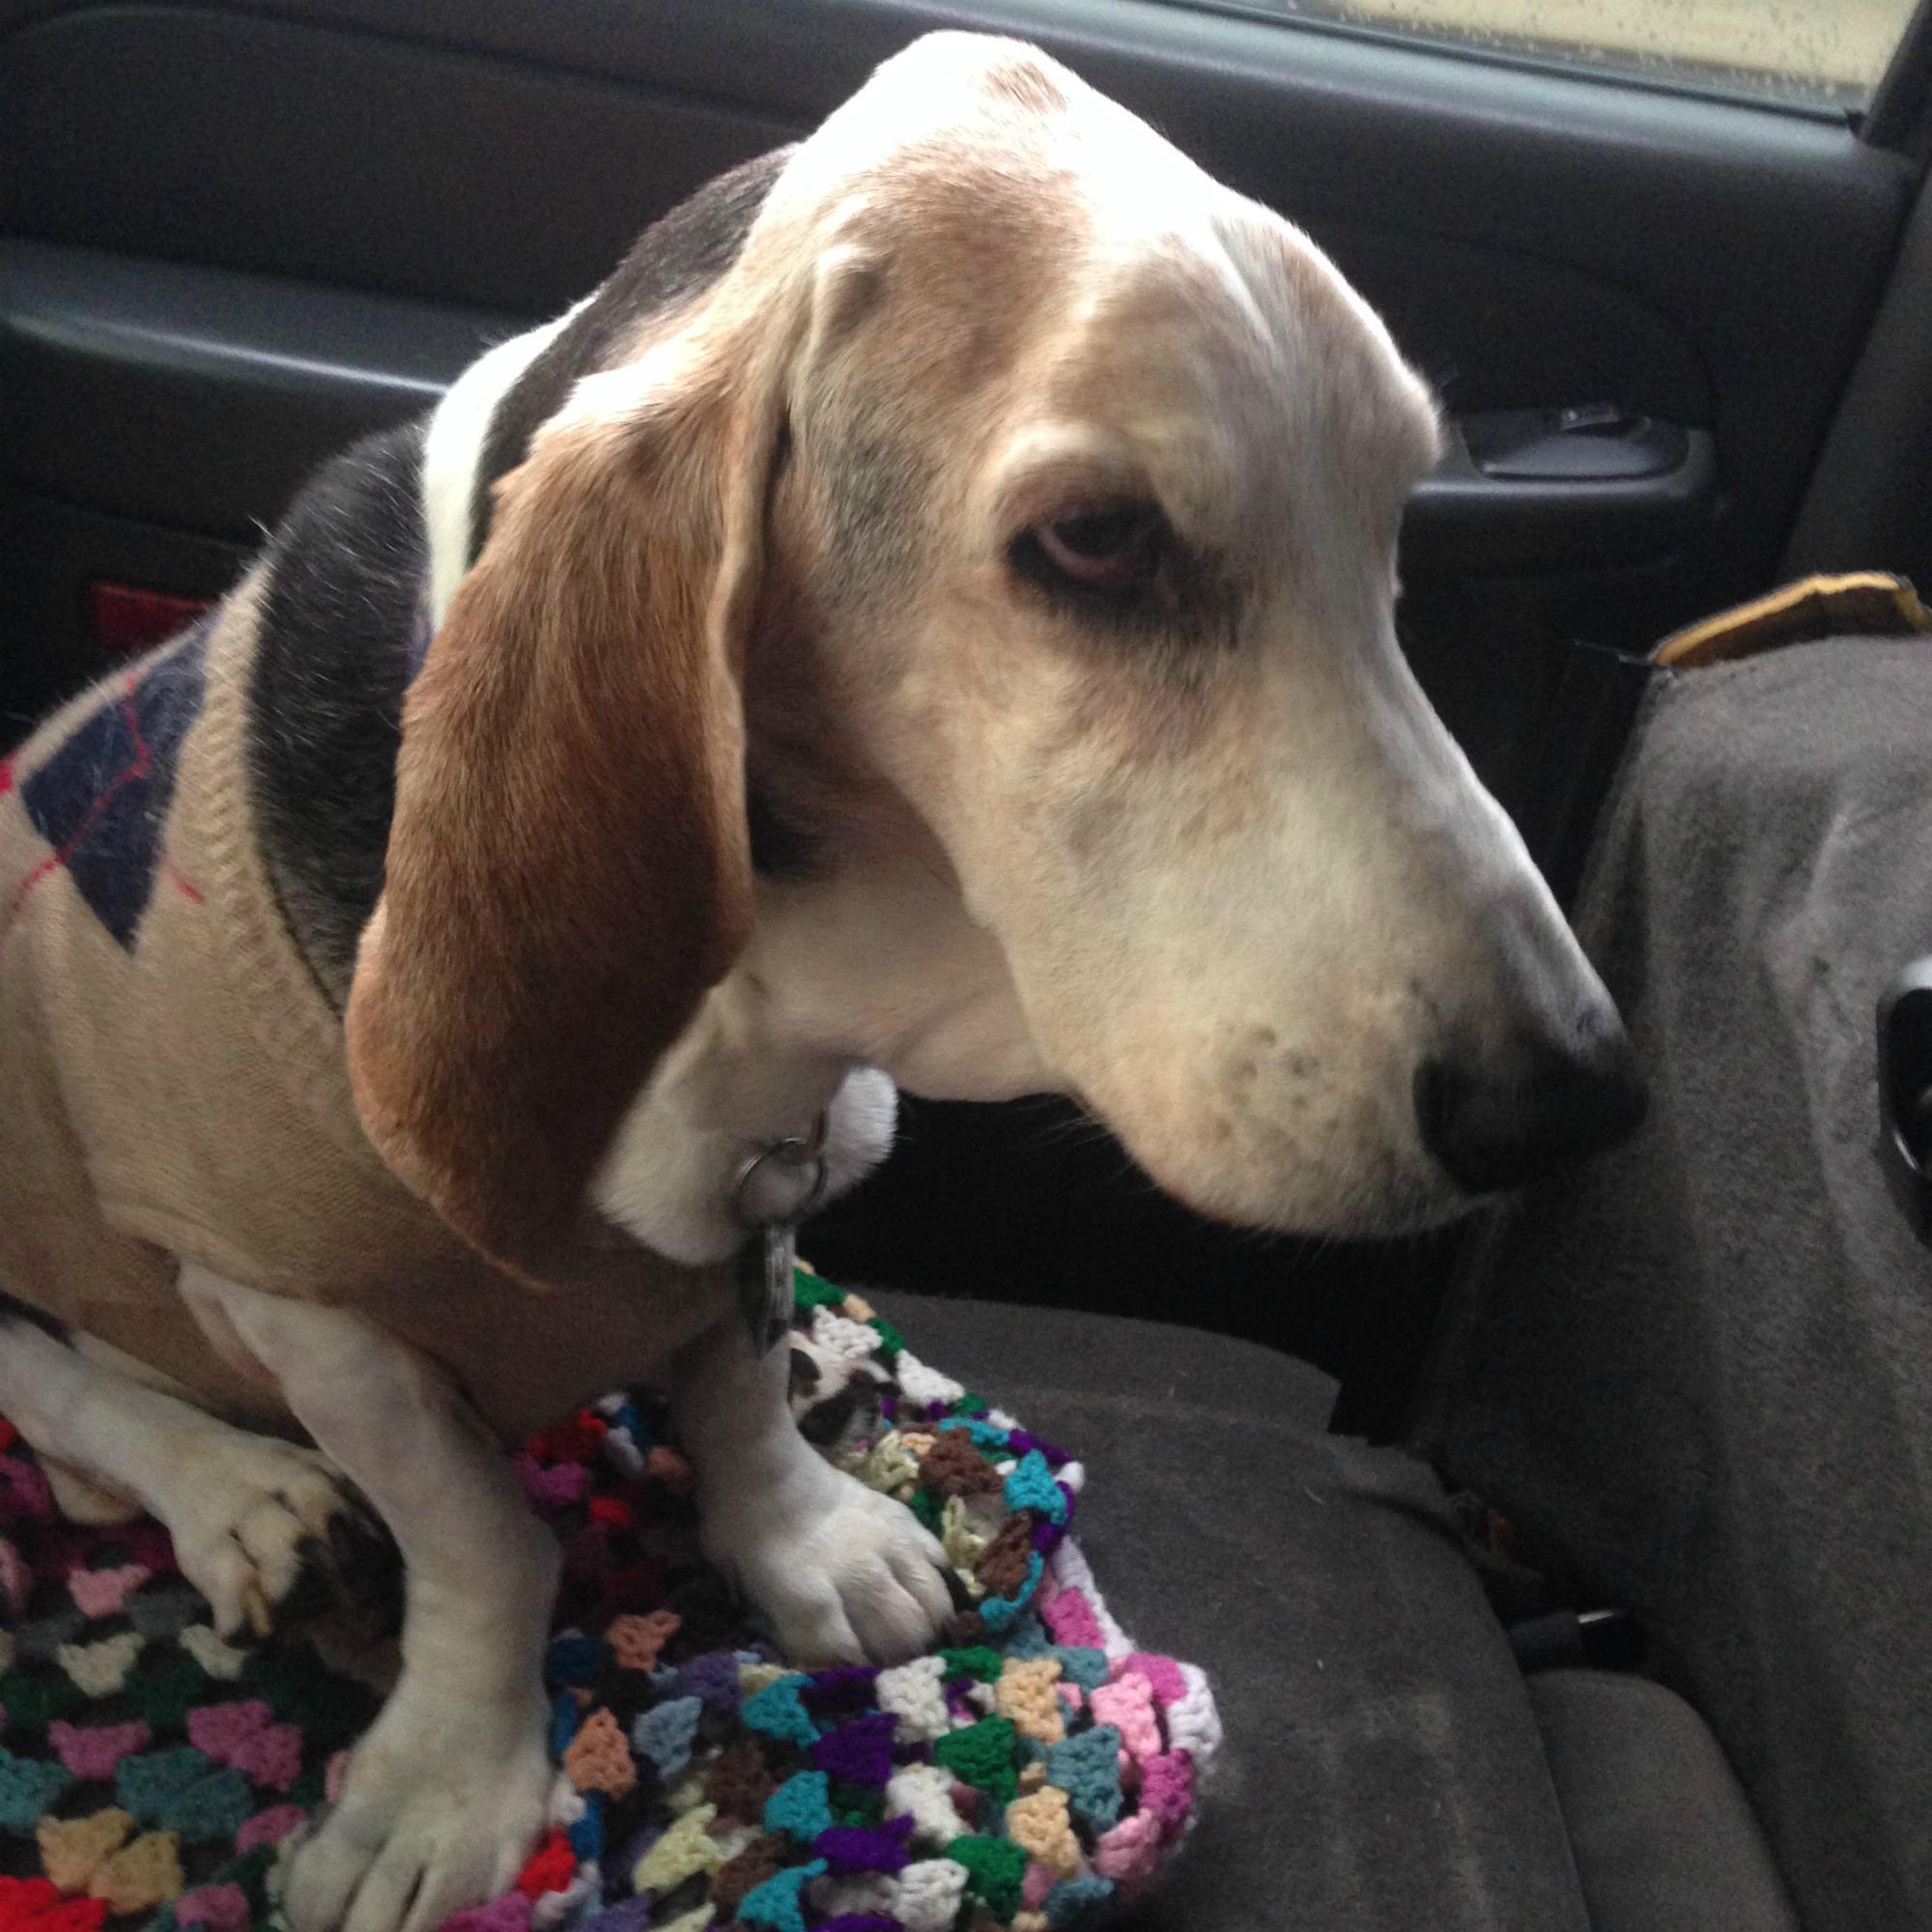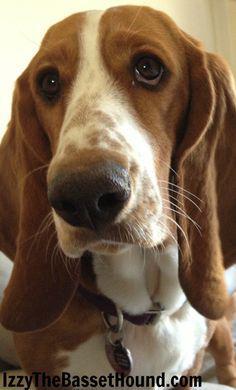The first image is the image on the left, the second image is the image on the right. Examine the images to the left and right. Is the description "One of the images shows at least one Basset Hound with something in their mouth." accurate? Answer yes or no. No. The first image is the image on the left, the second image is the image on the right. Examine the images to the left and right. Is the description "In one of the images there is a dog eating a carrot." accurate? Answer yes or no. No. 